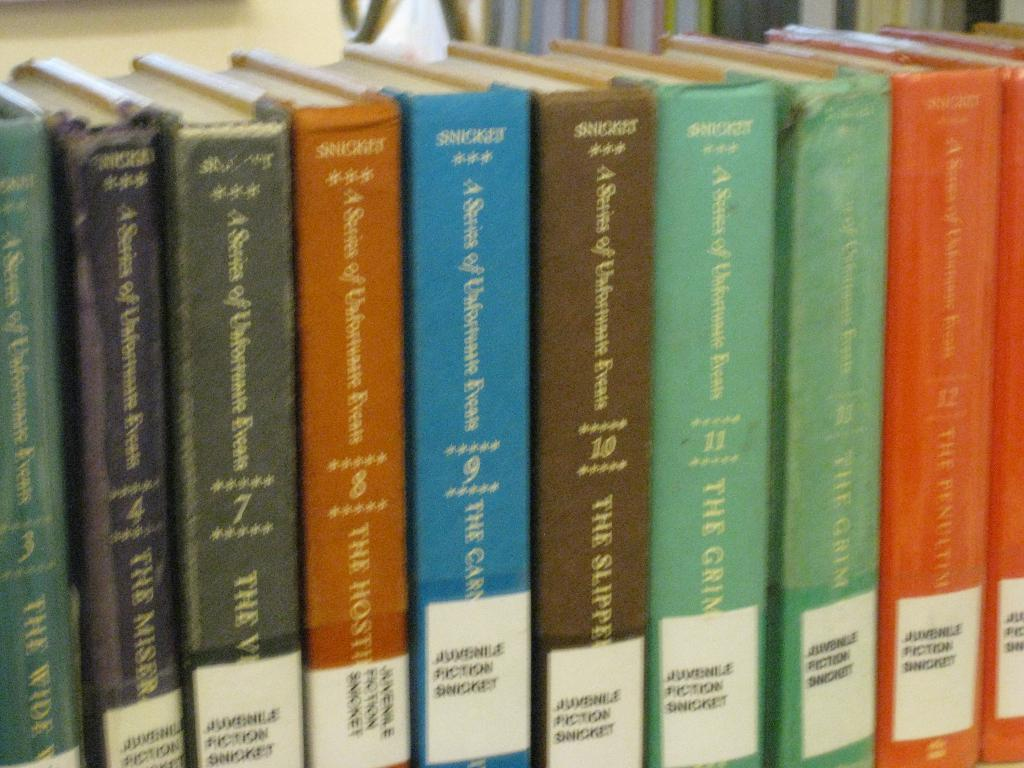<image>
Give a short and clear explanation of the subsequent image. Colorful books are lined up, all authored by Snicket. 